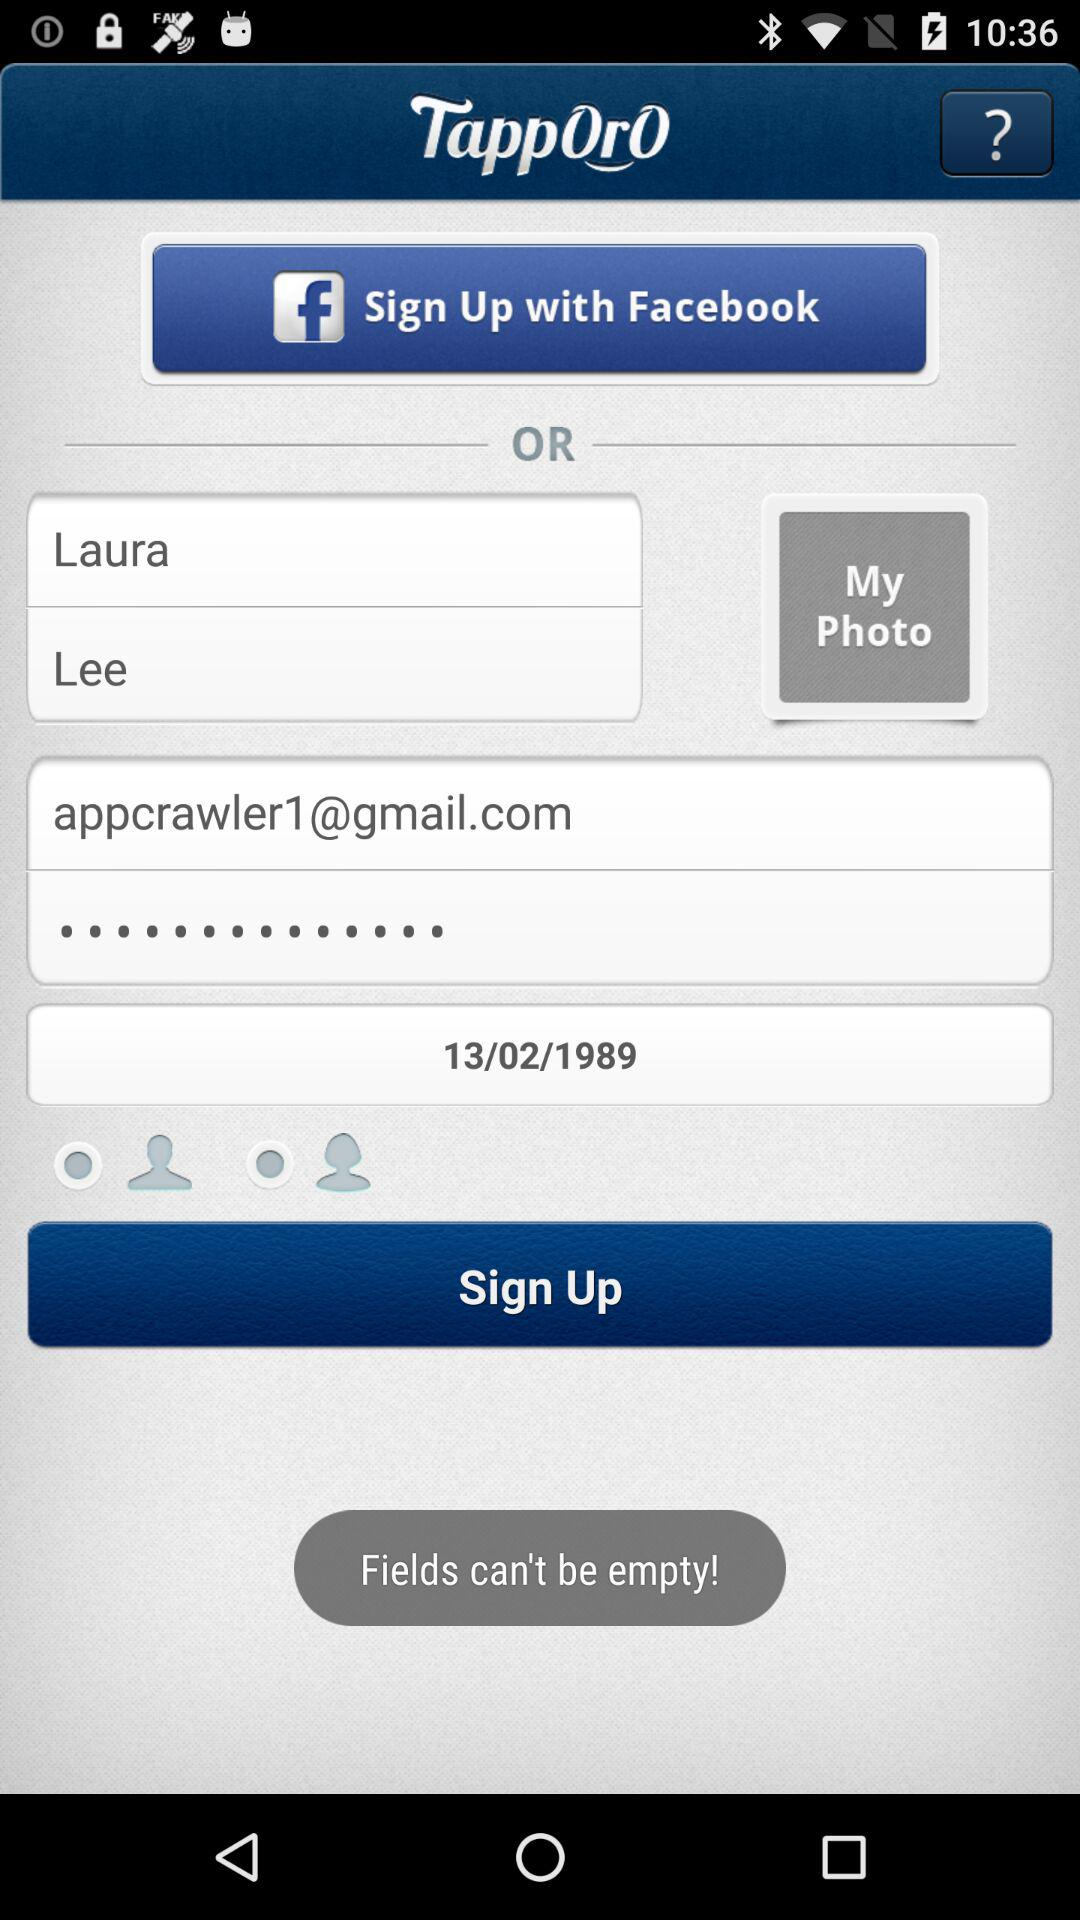What date is shown on the screen? The shown date on the screen is February 13, 1989. 